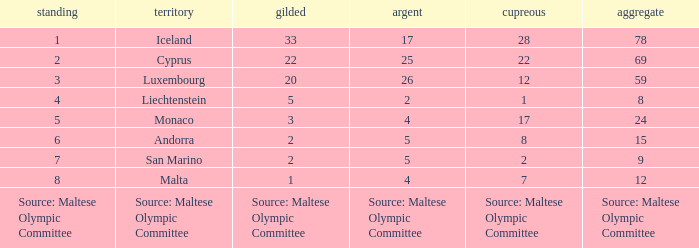What nation has 28 bronze medals? Iceland. 